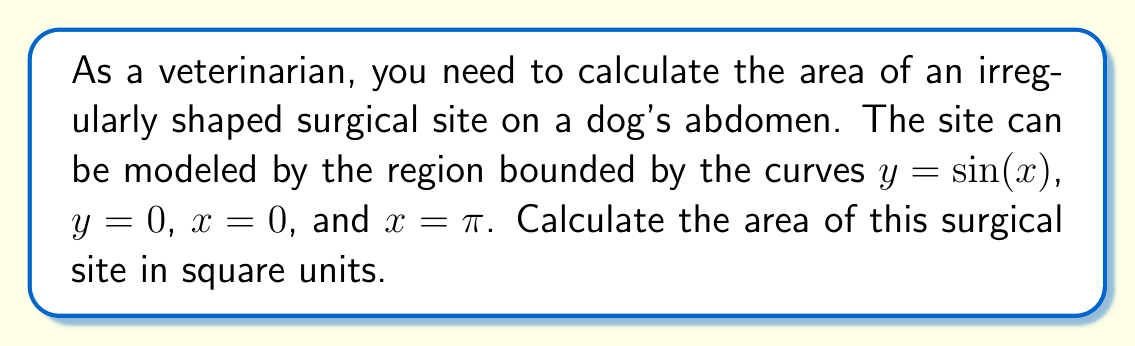Give your solution to this math problem. To find the area of this irregularly shaped region, we'll use integration. Here's how to approach it step-by-step:

1) The region is bounded by $y = \sin(x)$ above and $y = 0$ below, from $x = 0$ to $x = \pi$.

2) The area can be calculated using the definite integral:

   $$A = \int_0^\pi [\sin(x) - 0] dx$$

3) Simplify the integrand:

   $$A = \int_0^\pi \sin(x) dx$$

4) To integrate $\sin(x)$, we use the fact that its antiderivative is $-\cos(x)$:

   $$A = [-\cos(x)]_0^\pi$$

5) Evaluate the antiderivative at the limits:

   $$A = [-\cos(\pi)] - [-\cos(0)]$$

6) Simplify:
   $\cos(\pi) = -1$ and $\cos(0) = 1$

   $$A = [1] - [-1] = 1 + 1 = 2$$

Therefore, the area of the surgical site is 2 square units.

[asy]
import graph;
size(200,200);
real f(real x) {return sin(x);}
draw(graph(f,0,pi),blue);
draw((0,0)--(pi,0),black);
draw((0,0)--(0,1),black);
draw((pi,0)--(pi,0.1),black);
label("$y=\sin(x)$",(pi/2,0.7),N);
label("$x=\pi$",(pi,-0.1),S);
label("$x=0$",(0,-0.1),S);
label("$y=0$",(pi/2,-0.1),S);
fill((0,0)--(pi,0)--graph(f,0,pi)--cycle,paleblue);
[/asy]
Answer: 2 square units 